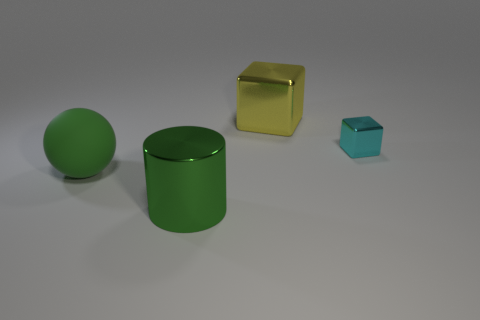Is there another metallic object that has the same size as the yellow shiny thing?
Give a very brief answer. Yes. There is a metallic object right of the yellow shiny cube; is its shape the same as the green matte object?
Give a very brief answer. No. Does the large green rubber object have the same shape as the green metal object?
Make the answer very short. No. Are there any other cyan objects of the same shape as the small cyan object?
Your answer should be compact. No. What shape is the green thing that is behind the green thing on the right side of the matte sphere?
Offer a very short reply. Sphere. What is the color of the big shiny thing in front of the rubber object?
Offer a very short reply. Green. The green thing that is made of the same material as the yellow object is what size?
Provide a short and direct response. Large. There is another thing that is the same shape as the small object; what size is it?
Your answer should be compact. Large. Are there any big shiny cylinders?
Offer a terse response. Yes. How many objects are either cylinders left of the big block or green cylinders?
Offer a terse response. 1. 